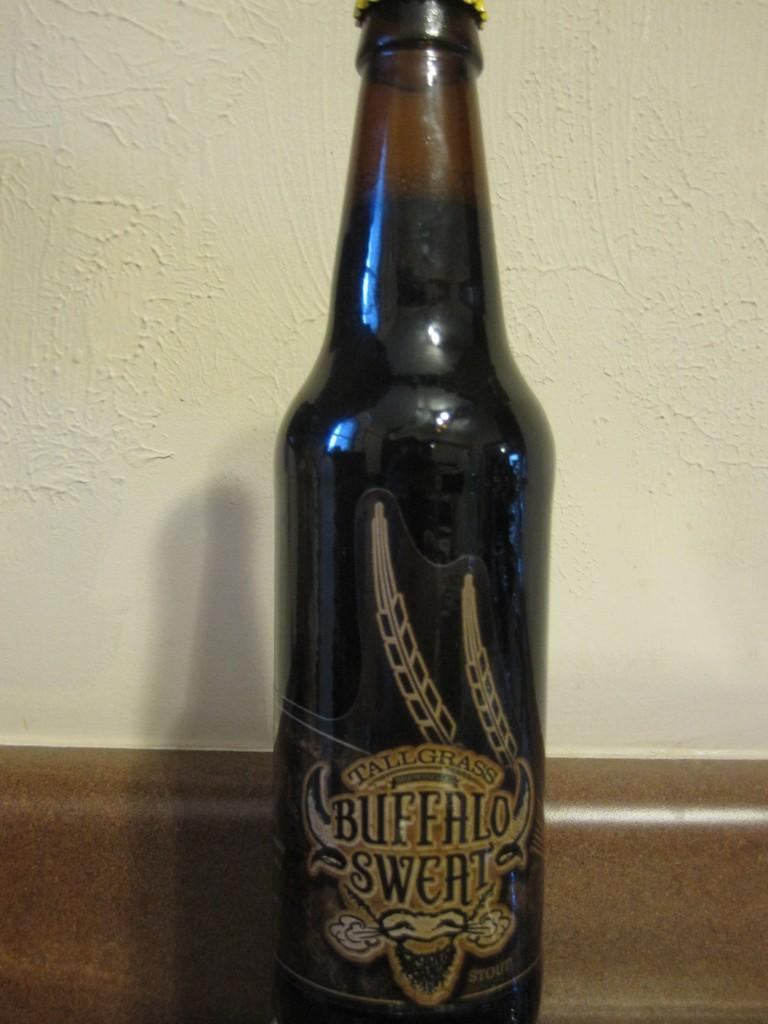<image>
Render a clear and concise summary of the photo. A brown bottle of Tallgrass Buffalo Sweat sits next to a wall. 